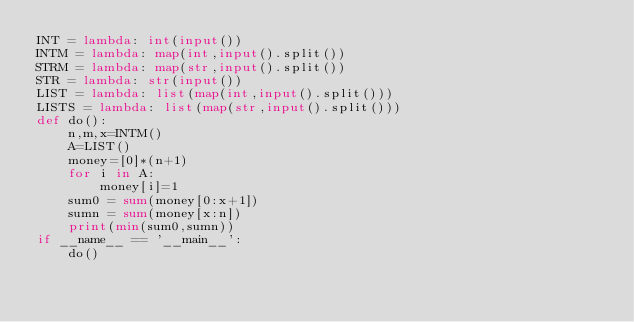Convert code to text. <code><loc_0><loc_0><loc_500><loc_500><_Python_>INT = lambda: int(input())
INTM = lambda: map(int,input().split())
STRM = lambda: map(str,input().split())
STR = lambda: str(input())
LIST = lambda: list(map(int,input().split()))
LISTS = lambda: list(map(str,input().split()))
def do():
    n,m,x=INTM()
    A=LIST()
    money=[0]*(n+1)
    for i in A:
        money[i]=1
    sum0 = sum(money[0:x+1])
    sumn = sum(money[x:n])
    print(min(sum0,sumn))
if __name__ == '__main__':
    do()</code> 